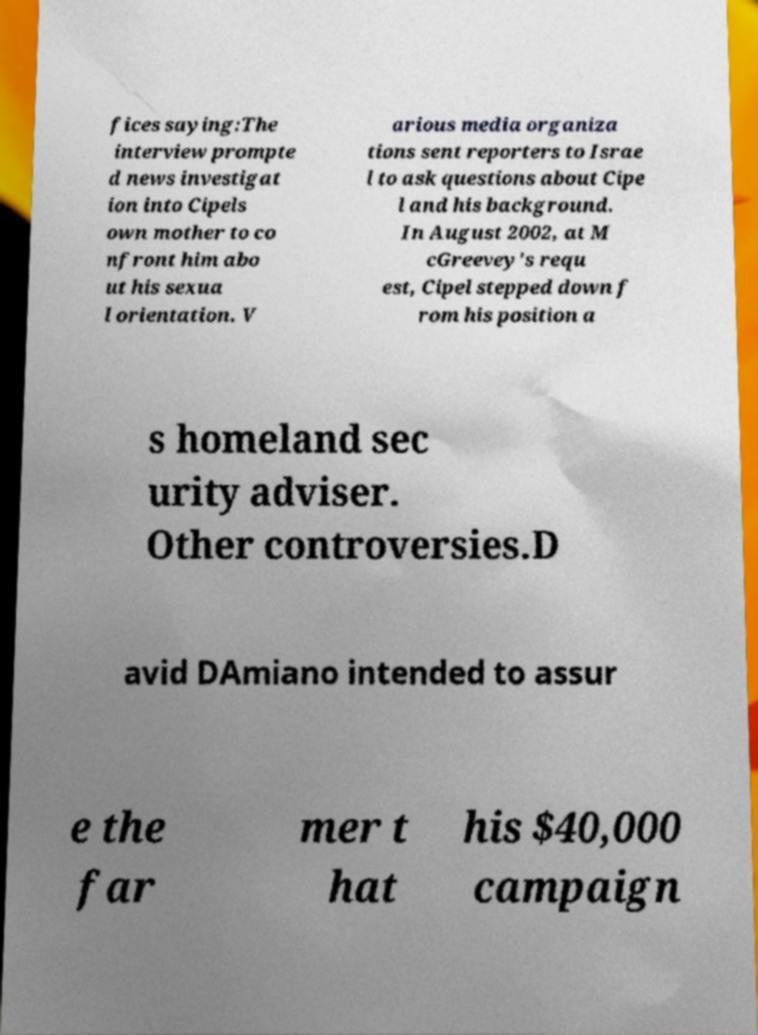Could you assist in decoding the text presented in this image and type it out clearly? fices saying:The interview prompte d news investigat ion into Cipels own mother to co nfront him abo ut his sexua l orientation. V arious media organiza tions sent reporters to Israe l to ask questions about Cipe l and his background. In August 2002, at M cGreevey's requ est, Cipel stepped down f rom his position a s homeland sec urity adviser. Other controversies.D avid DAmiano intended to assur e the far mer t hat his $40,000 campaign 